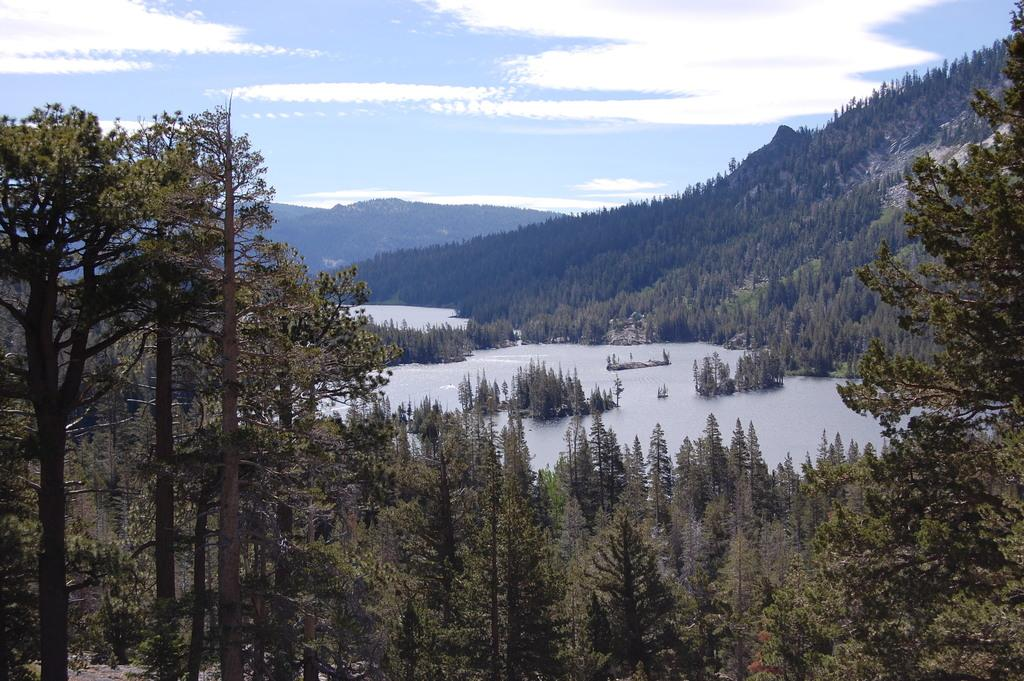What type of vegetation can be seen in the image? There are trees in the image. What natural element is visible in the image? There is water visible in the image. What geographical feature can be seen in the image? There are hills in the image. What is visible in the sky in the image? There are clouds visible in the image. What type of surprise can be seen in the image? There is no surprise present in the image; it features trees, water, hills, and clouds. What type of mouth can be seen in the image? There is no mouth present in the image. What type of carpenter can be seen working in the image? There is no carpenter present in the image. 